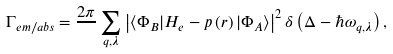Convert formula to latex. <formula><loc_0><loc_0><loc_500><loc_500>\Gamma _ { e m / a b s } = \frac { 2 \pi } { } \sum _ { q , \lambda } \left | \left \langle \Phi _ { B } | H _ { e } - p \left ( r \right ) | \Phi _ { A } \right \rangle \right | ^ { 2 } \delta \left ( \Delta - \hbar { \omega } _ { q , \lambda } \right ) ,</formula> 